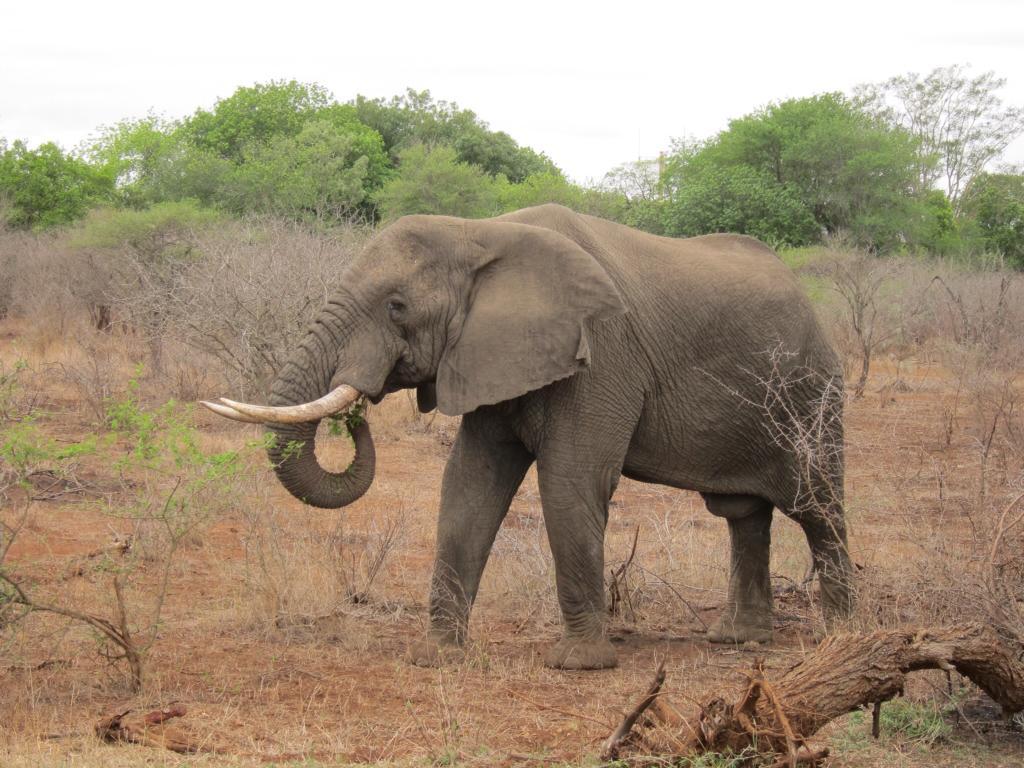How would you summarize this image in a sentence or two? In the picture I can see an elephant is standing on the ground. In the background I can see trees, plants and the sky. 